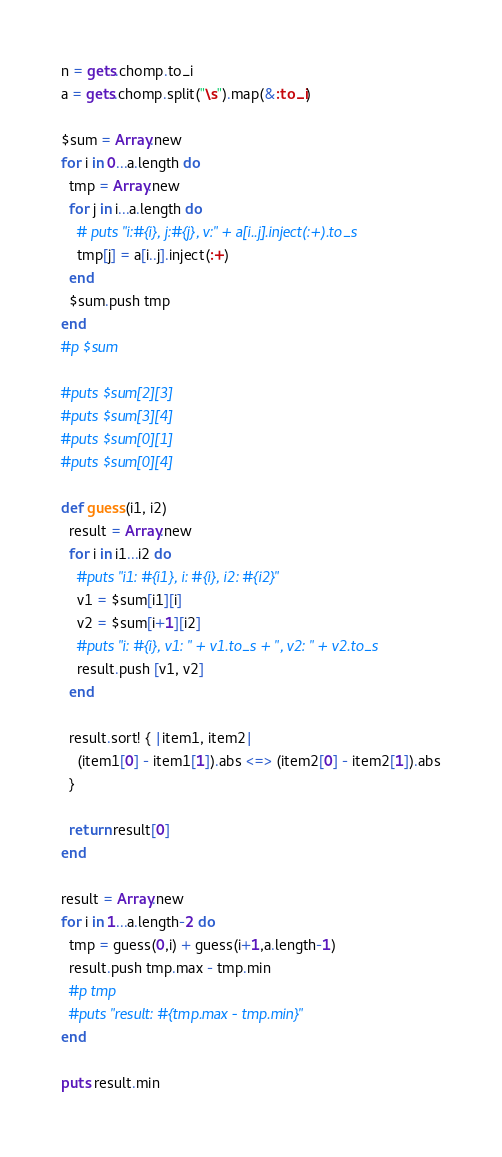<code> <loc_0><loc_0><loc_500><loc_500><_Ruby_>n = gets.chomp.to_i
a = gets.chomp.split("\s").map(&:to_i)

$sum = Array.new
for i in 0...a.length do
  tmp = Array.new
  for j in i...a.length do
    # puts "i:#{i}, j:#{j}, v:" + a[i..j].inject(:+).to_s
    tmp[j] = a[i..j].inject(:+)
  end
  $sum.push tmp
end
#p $sum

#puts $sum[2][3]
#puts $sum[3][4]
#puts $sum[0][1]
#puts $sum[0][4]

def guess(i1, i2)
  result = Array.new
  for i in i1...i2 do
    #puts "i1: #{i1}, i: #{i}, i2: #{i2}"
    v1 = $sum[i1][i]
    v2 = $sum[i+1][i2]
    #puts "i: #{i}, v1: " + v1.to_s + ", v2: " + v2.to_s
    result.push [v1, v2]
  end

  result.sort! { |item1, item2|
    (item1[0] - item1[1]).abs <=> (item2[0] - item2[1]).abs
  }

  return result[0]
end

result = Array.new
for i in 1...a.length-2 do
  tmp = guess(0,i) + guess(i+1,a.length-1)
  result.push tmp.max - tmp.min
  #p tmp
  #puts "result: #{tmp.max - tmp.min}"
end

puts result.min
</code> 